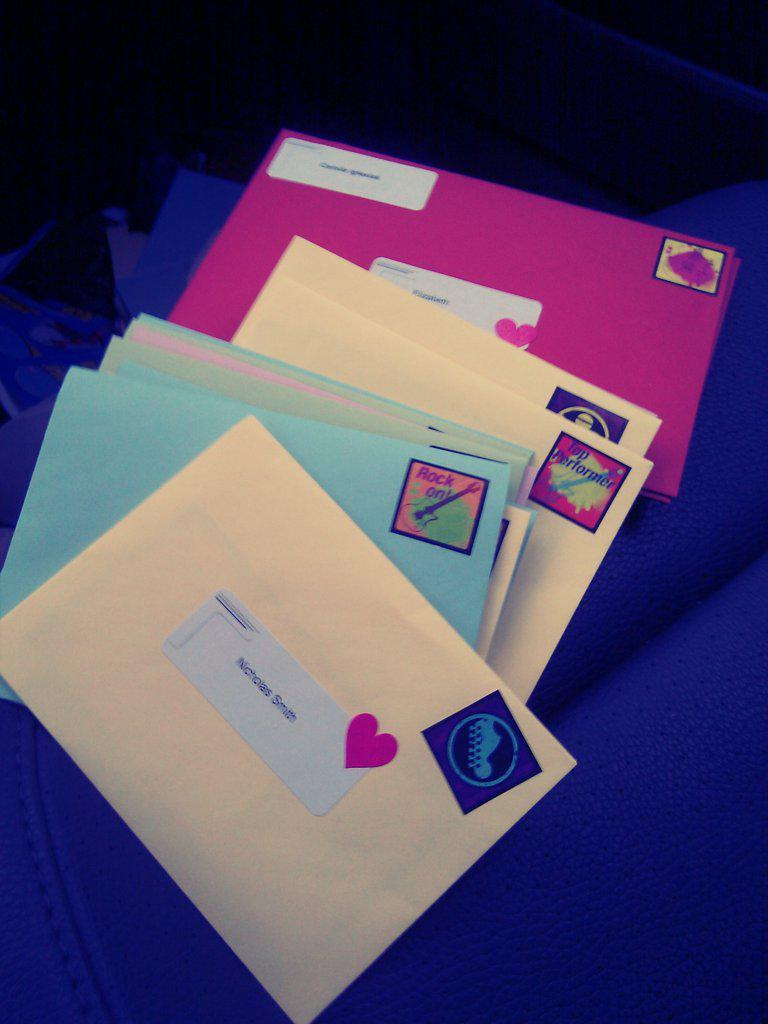<image>
Offer a succinct explanation of the picture presented. A stack of colorful envelopes with the top one addressed to Nicholas Smith. 